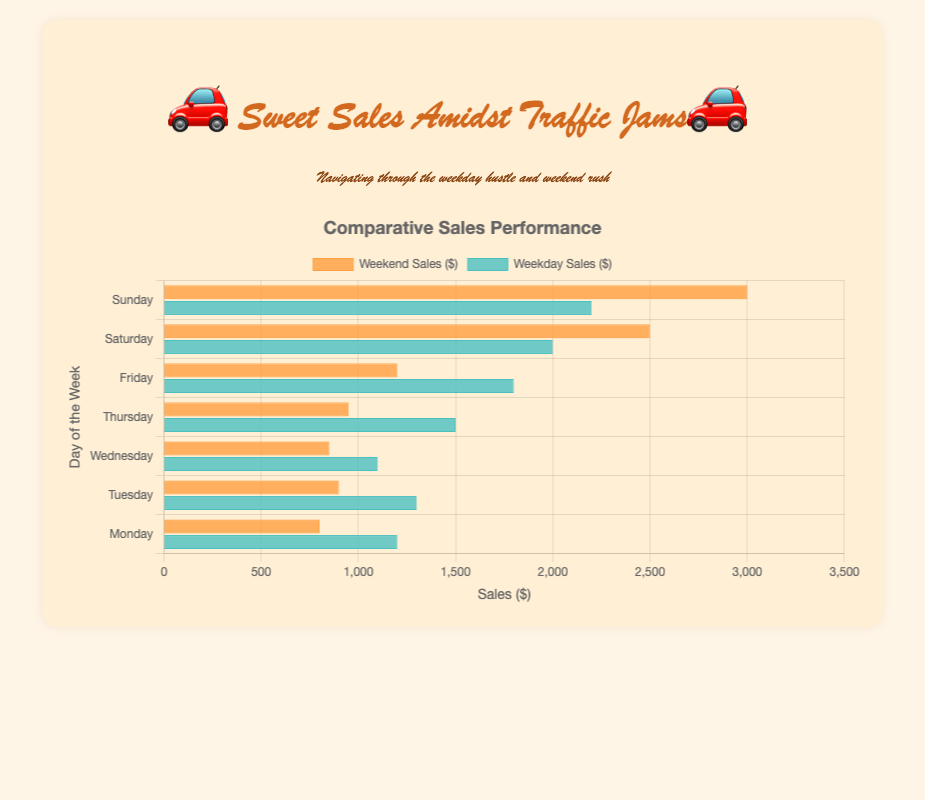What is the difference in sales between Weekdays and Weekends on Friday? To find the difference in sales between Weekdays and Weekends on Friday, subtract the Weekend Sales value from the Weekday Sales value for Friday. The Weekday Sales on Friday is $1800, and the Weekend Sales on Friday is $1200. So, the difference is $1800 - $1200.
Answer: $600 Which day has the highest Weekend Sales? Look at the lengths of the bars in the Weekend Sales category. The longest bar corresponds to Sunday with $3000 in sales.
Answer: Sunday On which day is the disparity between Weekday and Weekend Sales the greatest? Calculate the absolute difference between Weekday and Weekend Sales for each day. The largest difference is between Sunday Weekday Sales ($2200) and Weekend Sales ($3000), which is $800.
Answer: Sunday What is the total sales for Wednesday combining Weekday and Weekend? Sum the Weekday and Weekend Sales for Wednesday. The Weekday Sales are $1100 and the Weekend Sales are $850. So, $1100 + $850 = $1950.
Answer: $1950 What are the Weekday Sales on Thursday? Look for the bar labeled as Weekday Sales for Thursday. The Weekday Sales for Thursday is $1500.
Answer: $1500 On which day does the Weekend Sales exceed the Weekday Sales by $500? Look for a day where the difference between Weekend Sales and Weekday Sales is exactly $500. This occurs on Saturday where Weekend Sales are $2500 and Weekday Sales are $2000.
Answer: Saturday How do the Weekend Sales on Tuesday compare to the Weekday Sales on Tuesday? Compare the lengths of the bars for Tuesday. The Weekday Sales for Tuesday is $1300 and the Weekend Sales for Tuesday is $900. The Weekday Sales are $400 greater than the Weekend Sales.
Answer: Weekday Sales are higher by $400 What is the average of Weekday Sales across all days? Sum all the Weekday Sales values and divide by the number of days. Weekday Sales are $1200, $1300, $1100, $1500, $1800, $2000, and $2200. So, the average is ($1200 + $1300 + $1100 + $1500 + $1800 + $2000 + $2200) / 7 = $1585.71.
Answer: $1585.71 Which color represents Weekend Sales on the chart? Observe the color of the bars labeled as Weekend Sales. The color for Weekend Sales bars is orange.
Answer: Orange 